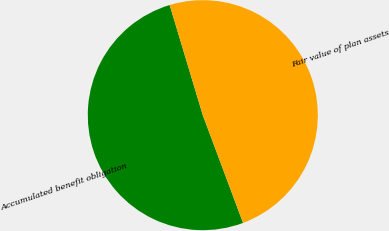<chart> <loc_0><loc_0><loc_500><loc_500><pie_chart><fcel>Accumulated benefit obligation<fcel>Fair value of plan assets<nl><fcel>51.04%<fcel>48.96%<nl></chart> 